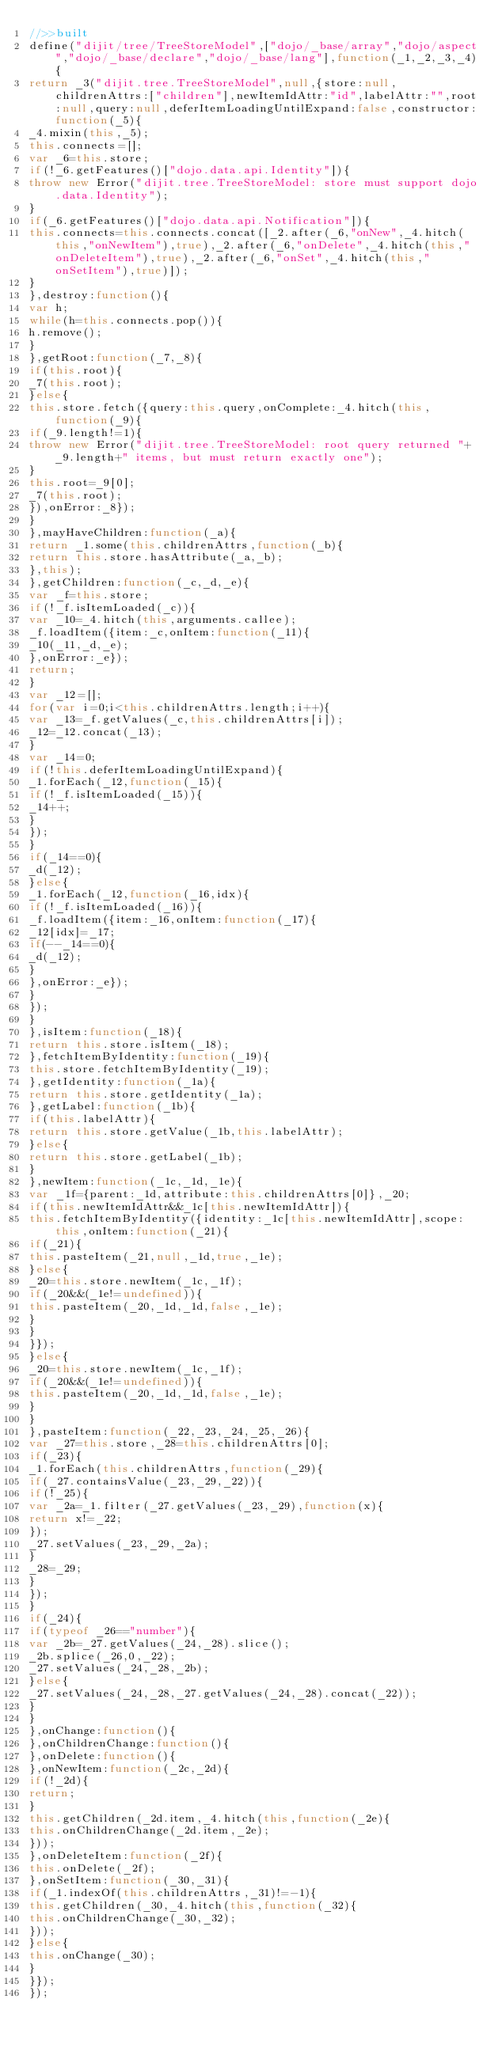Convert code to text. <code><loc_0><loc_0><loc_500><loc_500><_JavaScript_>//>>built
define("dijit/tree/TreeStoreModel",["dojo/_base/array","dojo/aspect","dojo/_base/declare","dojo/_base/lang"],function(_1,_2,_3,_4){
return _3("dijit.tree.TreeStoreModel",null,{store:null,childrenAttrs:["children"],newItemIdAttr:"id",labelAttr:"",root:null,query:null,deferItemLoadingUntilExpand:false,constructor:function(_5){
_4.mixin(this,_5);
this.connects=[];
var _6=this.store;
if(!_6.getFeatures()["dojo.data.api.Identity"]){
throw new Error("dijit.tree.TreeStoreModel: store must support dojo.data.Identity");
}
if(_6.getFeatures()["dojo.data.api.Notification"]){
this.connects=this.connects.concat([_2.after(_6,"onNew",_4.hitch(this,"onNewItem"),true),_2.after(_6,"onDelete",_4.hitch(this,"onDeleteItem"),true),_2.after(_6,"onSet",_4.hitch(this,"onSetItem"),true)]);
}
},destroy:function(){
var h;
while(h=this.connects.pop()){
h.remove();
}
},getRoot:function(_7,_8){
if(this.root){
_7(this.root);
}else{
this.store.fetch({query:this.query,onComplete:_4.hitch(this,function(_9){
if(_9.length!=1){
throw new Error("dijit.tree.TreeStoreModel: root query returned "+_9.length+" items, but must return exactly one");
}
this.root=_9[0];
_7(this.root);
}),onError:_8});
}
},mayHaveChildren:function(_a){
return _1.some(this.childrenAttrs,function(_b){
return this.store.hasAttribute(_a,_b);
},this);
},getChildren:function(_c,_d,_e){
var _f=this.store;
if(!_f.isItemLoaded(_c)){
var _10=_4.hitch(this,arguments.callee);
_f.loadItem({item:_c,onItem:function(_11){
_10(_11,_d,_e);
},onError:_e});
return;
}
var _12=[];
for(var i=0;i<this.childrenAttrs.length;i++){
var _13=_f.getValues(_c,this.childrenAttrs[i]);
_12=_12.concat(_13);
}
var _14=0;
if(!this.deferItemLoadingUntilExpand){
_1.forEach(_12,function(_15){
if(!_f.isItemLoaded(_15)){
_14++;
}
});
}
if(_14==0){
_d(_12);
}else{
_1.forEach(_12,function(_16,idx){
if(!_f.isItemLoaded(_16)){
_f.loadItem({item:_16,onItem:function(_17){
_12[idx]=_17;
if(--_14==0){
_d(_12);
}
},onError:_e});
}
});
}
},isItem:function(_18){
return this.store.isItem(_18);
},fetchItemByIdentity:function(_19){
this.store.fetchItemByIdentity(_19);
},getIdentity:function(_1a){
return this.store.getIdentity(_1a);
},getLabel:function(_1b){
if(this.labelAttr){
return this.store.getValue(_1b,this.labelAttr);
}else{
return this.store.getLabel(_1b);
}
},newItem:function(_1c,_1d,_1e){
var _1f={parent:_1d,attribute:this.childrenAttrs[0]},_20;
if(this.newItemIdAttr&&_1c[this.newItemIdAttr]){
this.fetchItemByIdentity({identity:_1c[this.newItemIdAttr],scope:this,onItem:function(_21){
if(_21){
this.pasteItem(_21,null,_1d,true,_1e);
}else{
_20=this.store.newItem(_1c,_1f);
if(_20&&(_1e!=undefined)){
this.pasteItem(_20,_1d,_1d,false,_1e);
}
}
}});
}else{
_20=this.store.newItem(_1c,_1f);
if(_20&&(_1e!=undefined)){
this.pasteItem(_20,_1d,_1d,false,_1e);
}
}
},pasteItem:function(_22,_23,_24,_25,_26){
var _27=this.store,_28=this.childrenAttrs[0];
if(_23){
_1.forEach(this.childrenAttrs,function(_29){
if(_27.containsValue(_23,_29,_22)){
if(!_25){
var _2a=_1.filter(_27.getValues(_23,_29),function(x){
return x!=_22;
});
_27.setValues(_23,_29,_2a);
}
_28=_29;
}
});
}
if(_24){
if(typeof _26=="number"){
var _2b=_27.getValues(_24,_28).slice();
_2b.splice(_26,0,_22);
_27.setValues(_24,_28,_2b);
}else{
_27.setValues(_24,_28,_27.getValues(_24,_28).concat(_22));
}
}
},onChange:function(){
},onChildrenChange:function(){
},onDelete:function(){
},onNewItem:function(_2c,_2d){
if(!_2d){
return;
}
this.getChildren(_2d.item,_4.hitch(this,function(_2e){
this.onChildrenChange(_2d.item,_2e);
}));
},onDeleteItem:function(_2f){
this.onDelete(_2f);
},onSetItem:function(_30,_31){
if(_1.indexOf(this.childrenAttrs,_31)!=-1){
this.getChildren(_30,_4.hitch(this,function(_32){
this.onChildrenChange(_30,_32);
}));
}else{
this.onChange(_30);
}
}});
});
</code> 